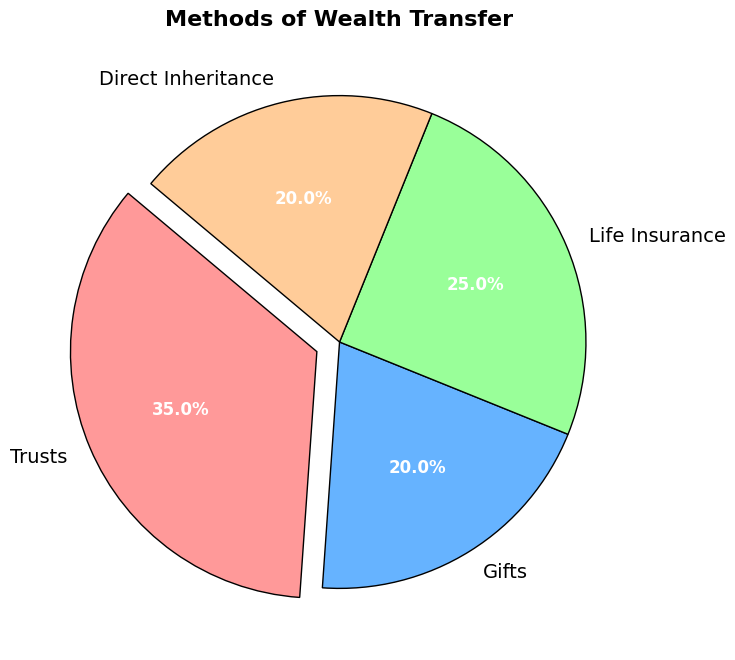What percentage of the wealth transfer methods is accounted for by Life Insurance? Look for the slice labeled "Life Insurance" and note the percentage displayed.
Answer: 25% Which wealth transfer method has the smallest percentage? Compare the given percentages of all methods and identify the smallest one. Both Gifts and Direct Inheritance have the same percentage.
Answer: Gifts and Direct Inheritance What is the combined percentage of Gifts and Direct Inheritance? Add the percentages of Gifts and Direct Inheritance: 20% + 20%.
Answer: 40% Which method accounts for 35% of the wealth transfer? Identify the slice that indicates 35% and shows which method it represents.
Answer: Trusts Is the percentage of Life Insurance greater than the percentage of Gifts? Compare the percentages of Life Insurance (25%) and Gifts (20%).
Answer: Yes What is the color of the slice representing Trusts? Observe the pie chart and identify the color of the "Trusts" slice. It is typically visually distinct.
Answer: Red (or the first color specified) Summarize the cumulative percentage of wealth transfer methods excluding Trusts. Add up the percentages of all methods except Trusts: 20% (Gifts) + 25% (Life Insurance) + 20% (Direct Inheritance).
Answer: 65% What is the difference in percentage between Trusts and Direct Inheritance? Subtract the percentage of Direct Inheritance (20%) from the percentage of Trusts (35%).
Answer: 15% In terms of visual prominence, which method of wealth transfer is most highlighted and why? Look for the slice that seems to "pop out" the most, often with an "exploded" effect or larger size. This indicates visual emphasis.
Answer: Trusts, because it is exploded out from the rest of the chart What is the average percentage of all wealth transfer methods shown? Sum the percentages of all methods and divide by the number of methods: (35% + 20% + 25% + 20%) / 4.
Answer: 25% 